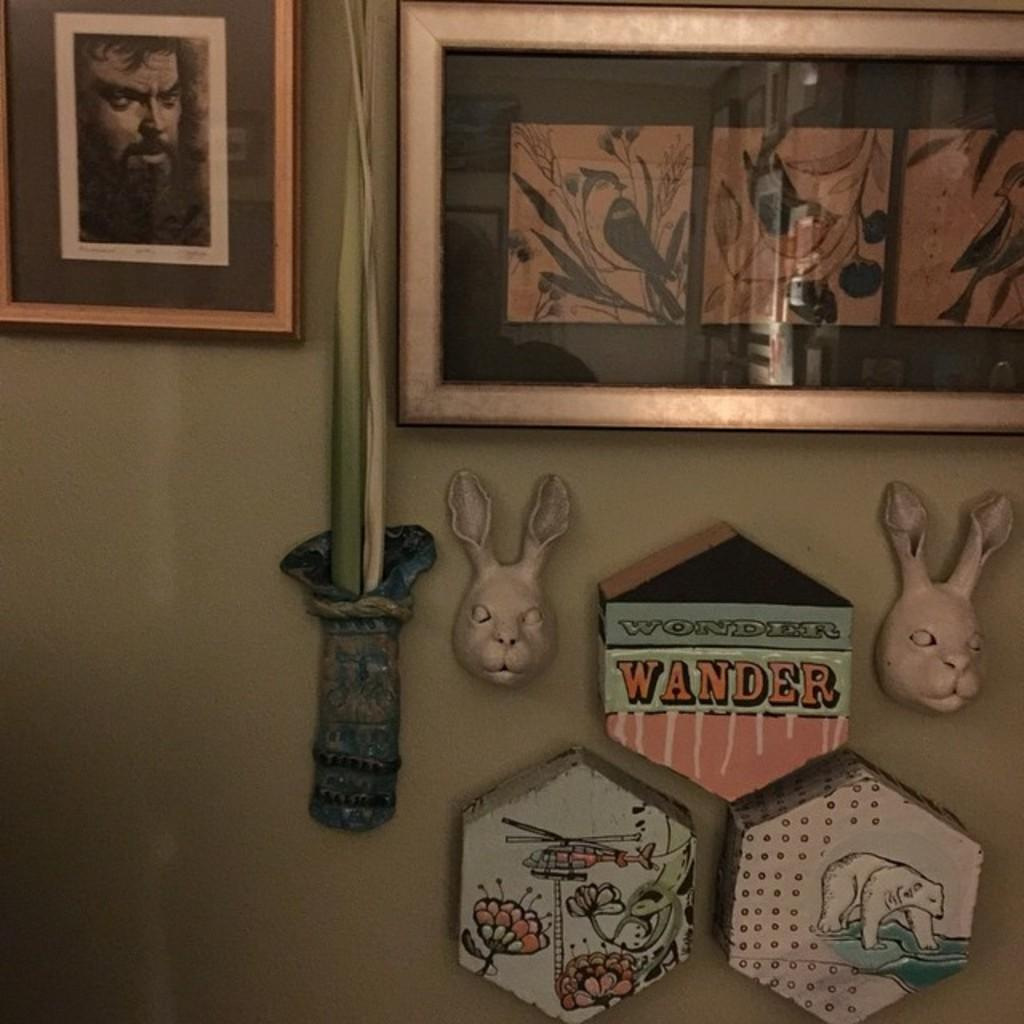What types of decorations are on the wall in the image? There are picture frames and sculptures on the wall in the image. Are there any other types of decorations at the bottom of the wall? Yes, there are objects with images painted on them at the bottom. How many sisters are depicted in the ring on the wall? There is no ring present in the image, and therefore no sisters can be depicted in it. 